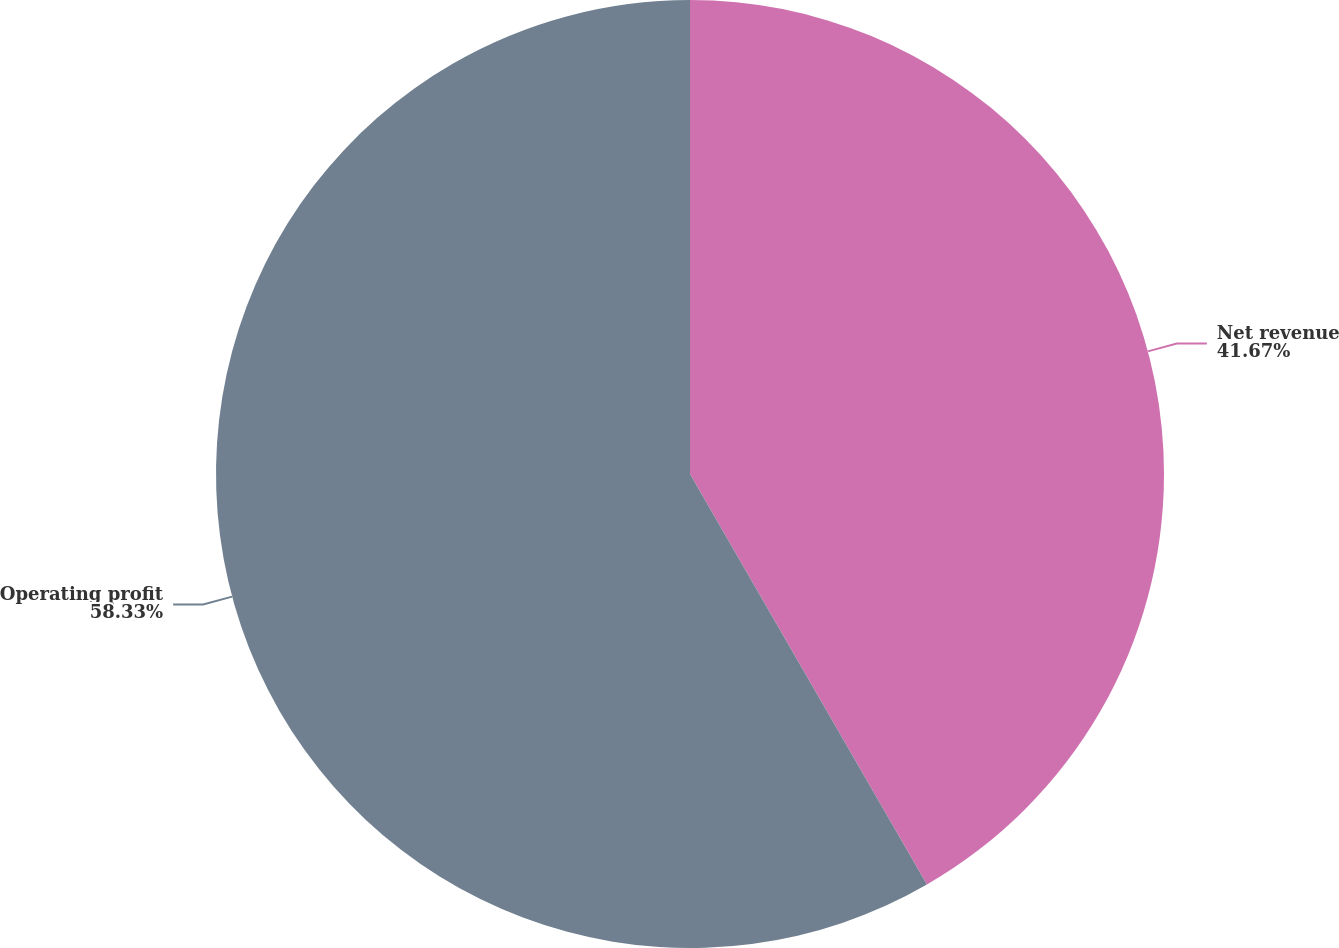Convert chart. <chart><loc_0><loc_0><loc_500><loc_500><pie_chart><fcel>Net revenue<fcel>Operating profit<nl><fcel>41.67%<fcel>58.33%<nl></chart> 